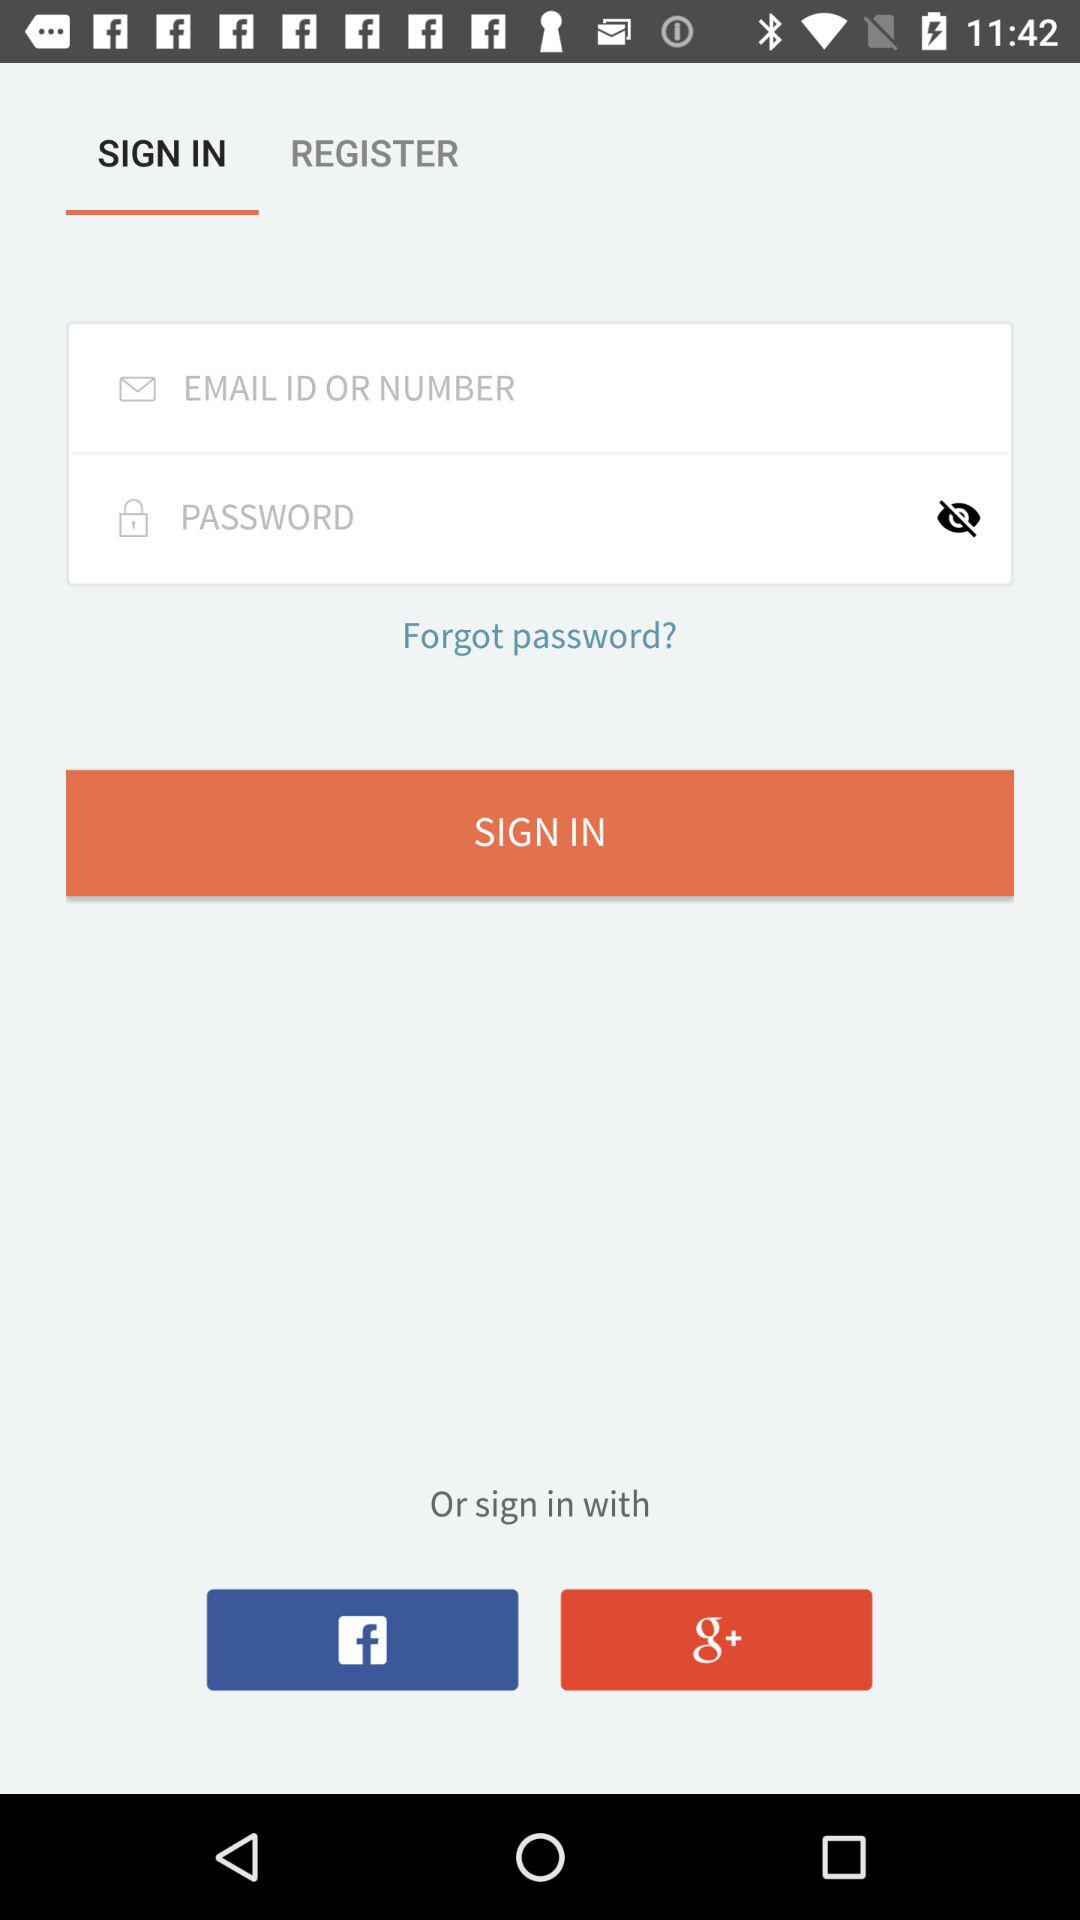What applications can be used to sign in to a profile? The applications are "Facebook" and "Google Plus". 